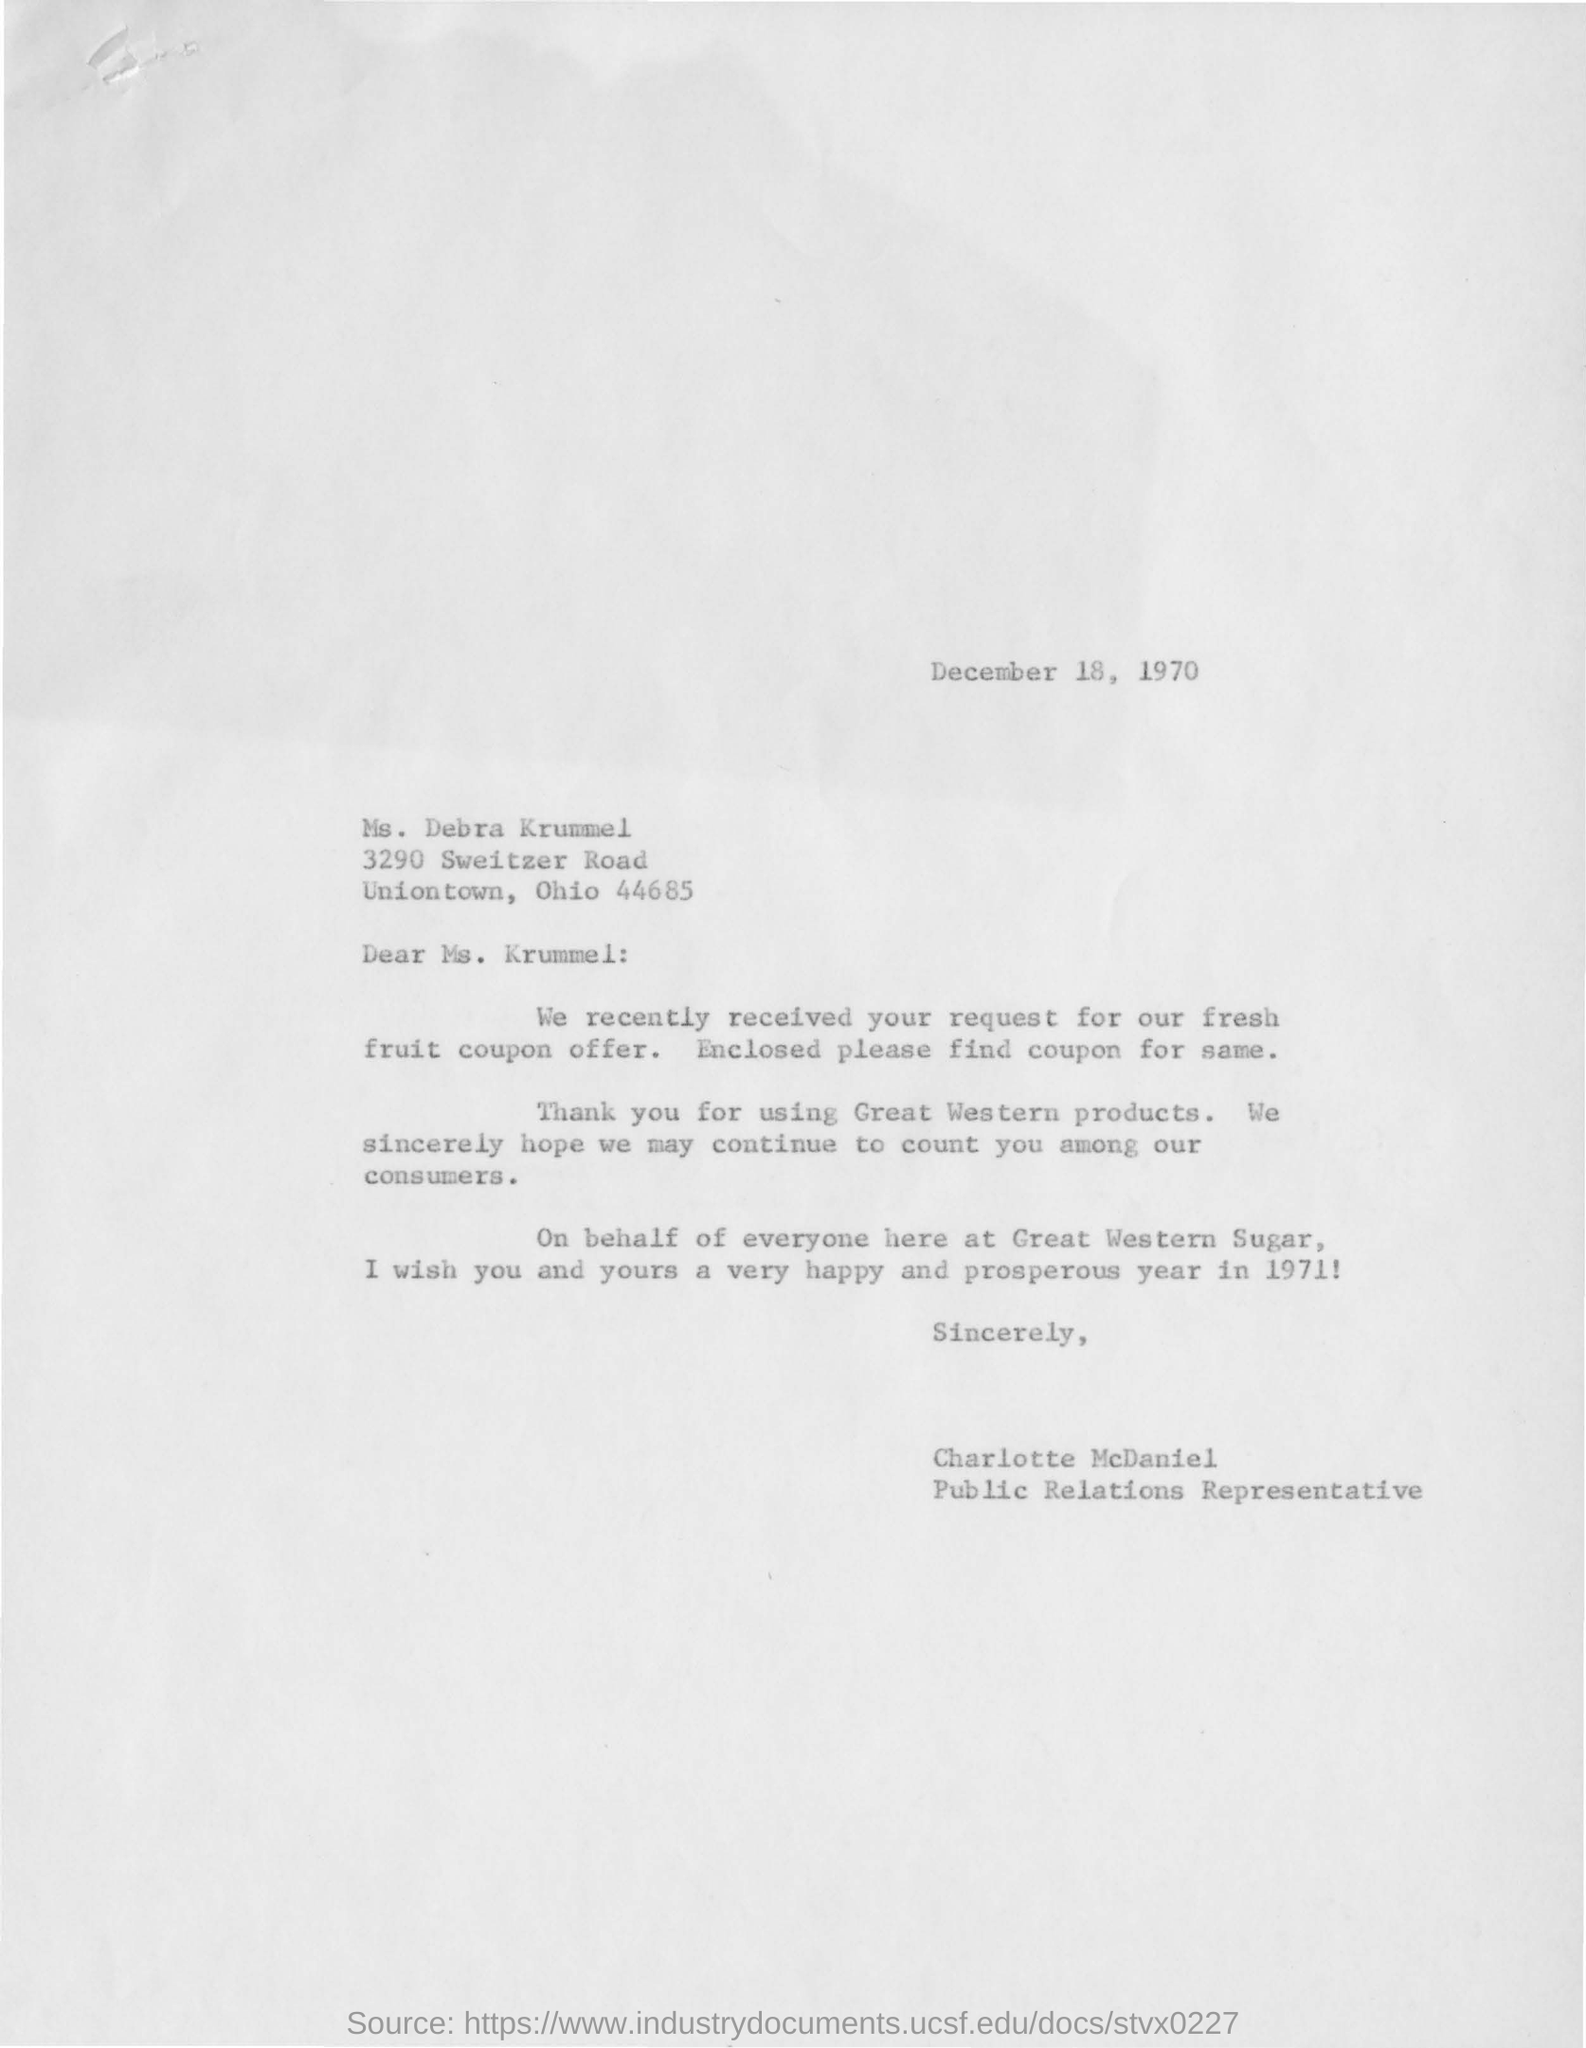Who is this letter sent to?
Make the answer very short. Ms. Debra Krummel. What is the request they have received in the letter ?
Keep it short and to the point. Request for our fresh fruit coupon offer. Which companys products is mentioned ?
Your answer should be compact. Great western. Who is the public relations representative ?
Make the answer very short. Charlotte McDaniel. On which date this letter was written ?
Make the answer very short. December 18 , 1970. 